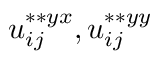Convert formula to latex. <formula><loc_0><loc_0><loc_500><loc_500>u _ { i j } ^ { \ast \ast { y x } } , u _ { i j } ^ { \ast \ast { y y } }</formula> 